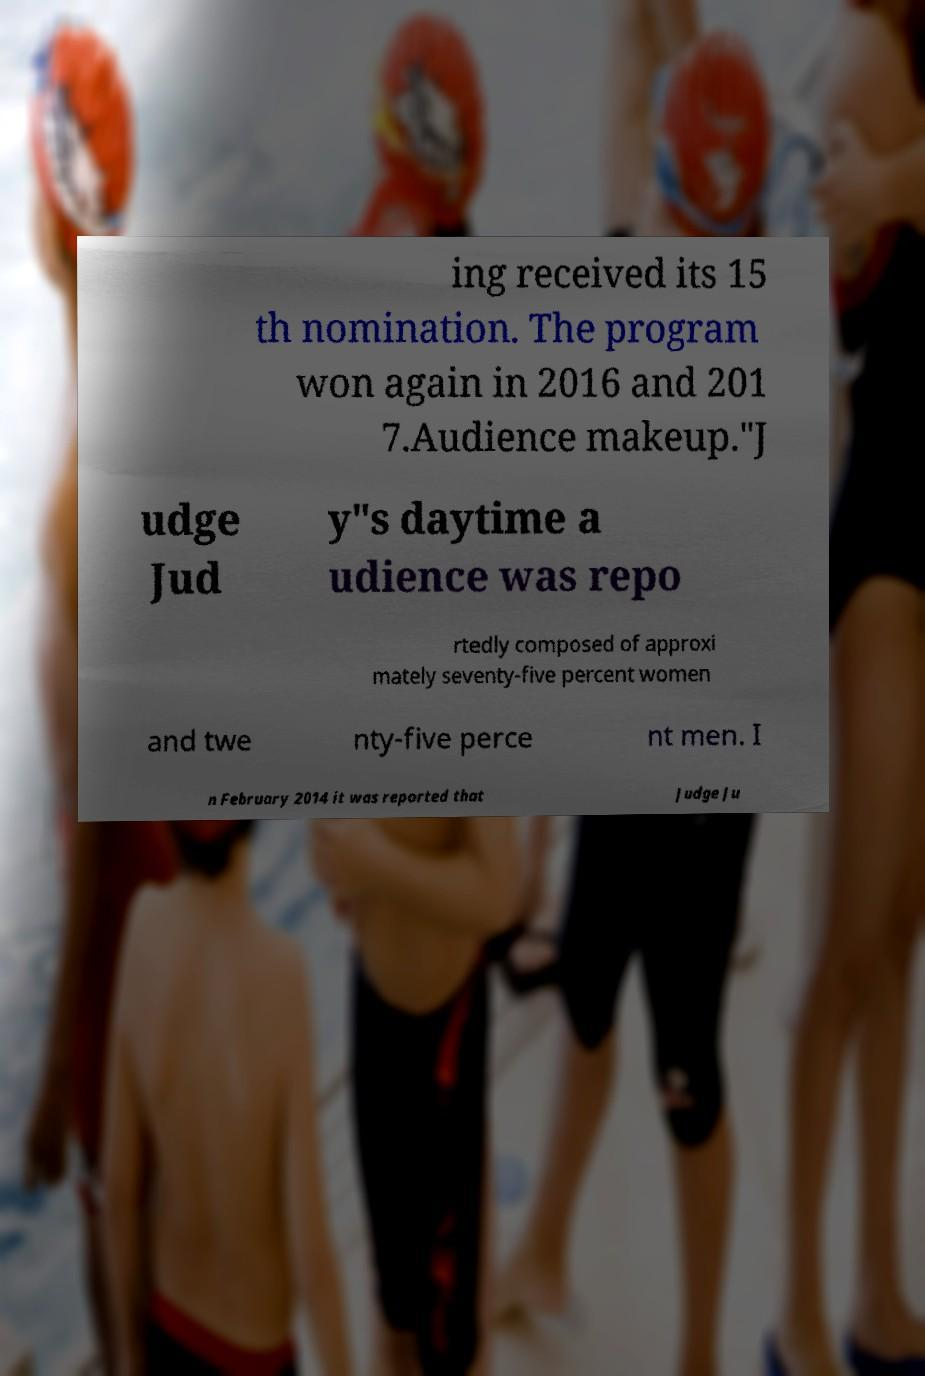There's text embedded in this image that I need extracted. Can you transcribe it verbatim? ing received its 15 th nomination. The program won again in 2016 and 201 7.Audience makeup."J udge Jud y"s daytime a udience was repo rtedly composed of approxi mately seventy-five percent women and twe nty-five perce nt men. I n February 2014 it was reported that Judge Ju 